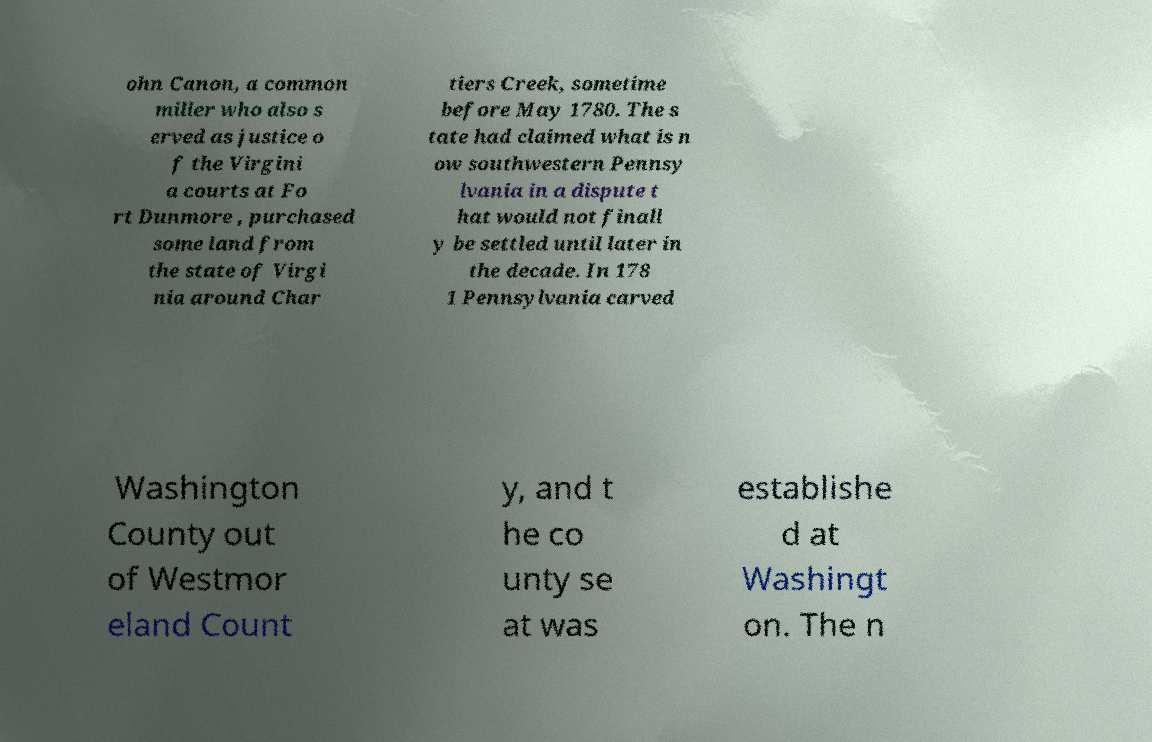I need the written content from this picture converted into text. Can you do that? ohn Canon, a common miller who also s erved as justice o f the Virgini a courts at Fo rt Dunmore , purchased some land from the state of Virgi nia around Char tiers Creek, sometime before May 1780. The s tate had claimed what is n ow southwestern Pennsy lvania in a dispute t hat would not finall y be settled until later in the decade. In 178 1 Pennsylvania carved Washington County out of Westmor eland Count y, and t he co unty se at was establishe d at Washingt on. The n 